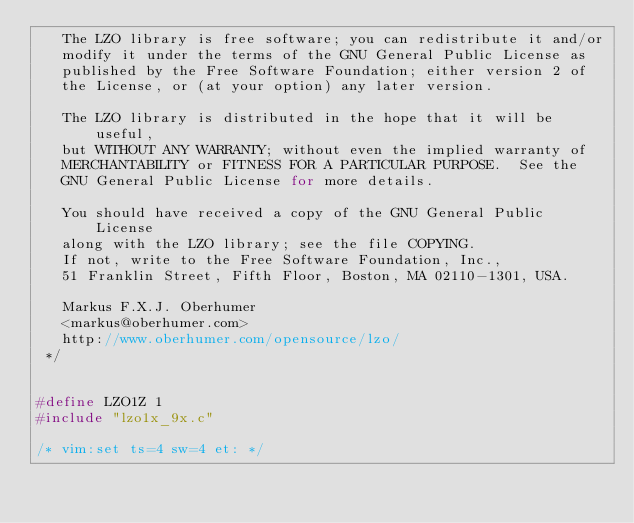Convert code to text. <code><loc_0><loc_0><loc_500><loc_500><_C_>   The LZO library is free software; you can redistribute it and/or
   modify it under the terms of the GNU General Public License as
   published by the Free Software Foundation; either version 2 of
   the License, or (at your option) any later version.

   The LZO library is distributed in the hope that it will be useful,
   but WITHOUT ANY WARRANTY; without even the implied warranty of
   MERCHANTABILITY or FITNESS FOR A PARTICULAR PURPOSE.  See the
   GNU General Public License for more details.

   You should have received a copy of the GNU General Public License
   along with the LZO library; see the file COPYING.
   If not, write to the Free Software Foundation, Inc.,
   51 Franklin Street, Fifth Floor, Boston, MA 02110-1301, USA.

   Markus F.X.J. Oberhumer
   <markus@oberhumer.com>
   http://www.oberhumer.com/opensource/lzo/
 */


#define LZO1Z 1
#include "lzo1x_9x.c"

/* vim:set ts=4 sw=4 et: */
</code> 